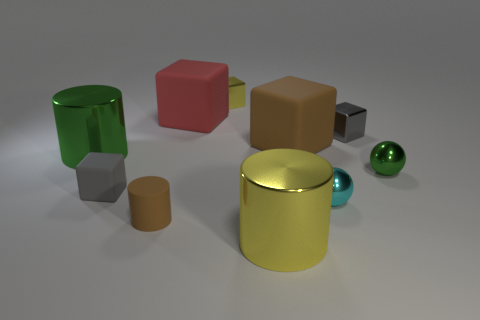What is the shape of the green object that is the same size as the brown matte cylinder?
Provide a succinct answer. Sphere. Are there any tiny objects right of the red matte thing?
Provide a short and direct response. Yes. Do the yellow object that is in front of the red matte cube and the small gray thing behind the tiny matte cube have the same material?
Make the answer very short. Yes. How many yellow cylinders are the same size as the brown cylinder?
Your answer should be very brief. 0. The object that is the same color as the tiny rubber block is what shape?
Ensure brevity in your answer.  Cube. What is the material of the large cylinder on the right side of the big green metallic cylinder?
Ensure brevity in your answer.  Metal. How many other small rubber things are the same shape as the tiny green thing?
Your response must be concise. 0. What shape is the tiny yellow object that is made of the same material as the yellow cylinder?
Give a very brief answer. Cube. There is a yellow object behind the small metallic cube on the right side of the big metallic cylinder that is in front of the large green cylinder; what shape is it?
Keep it short and to the point. Cube. Are there more yellow metal cylinders than small blue rubber blocks?
Make the answer very short. Yes. 